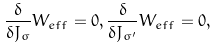<formula> <loc_0><loc_0><loc_500><loc_500>\frac { \delta } { \delta J _ { \sigma } } W _ { e f f } = 0 , \frac { \delta } { \delta J _ { \sigma ^ { \prime } } } W _ { e f f } = 0 ,</formula> 